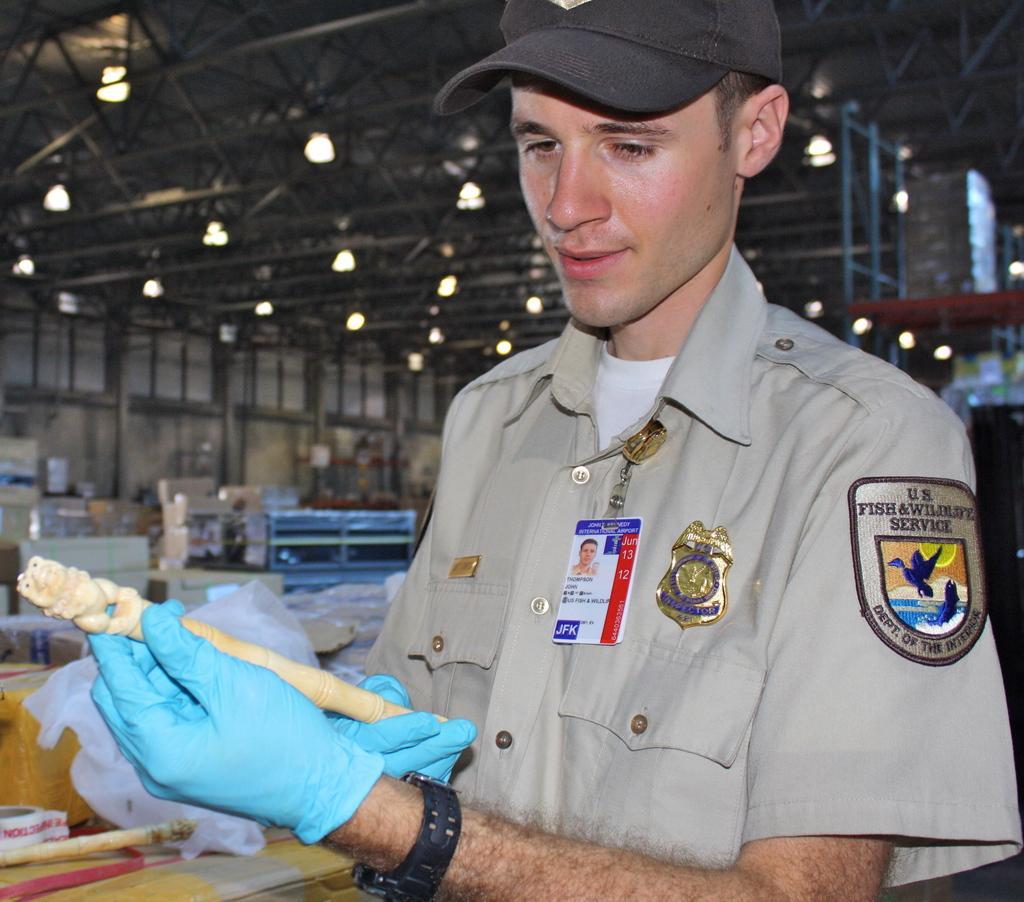Could you give a brief overview of what you see in this image? In this picture we can see a man wore a cap, watch, gloves and holding a stick with his hand and smiling and at the back of him we can see the lights, rods, plastic covers and some objects and in the background we can see the wall. 